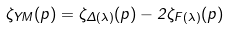Convert formula to latex. <formula><loc_0><loc_0><loc_500><loc_500>\zeta _ { Y M } ( p ) = \zeta _ { \Delta ( \lambda ) } ( p ) - 2 \zeta _ { F ( \lambda ) } ( p )</formula> 